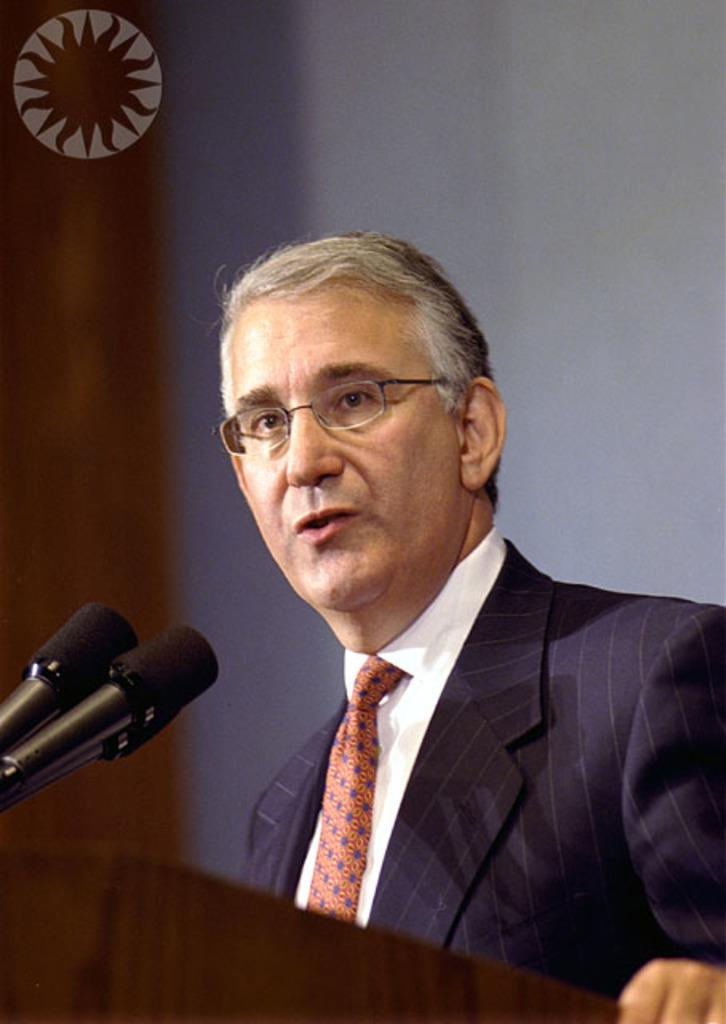Who is the main subject in the image? There is a man in the image. What is the man wearing? The man is wearing spectacles. What is the man doing in the image? The man is speaking in front of microphones. What type of leaf is being used to generate heat in the image? There is no leaf or heat generation present in the image; it features a man wearing spectacles and speaking in front of microphones. 